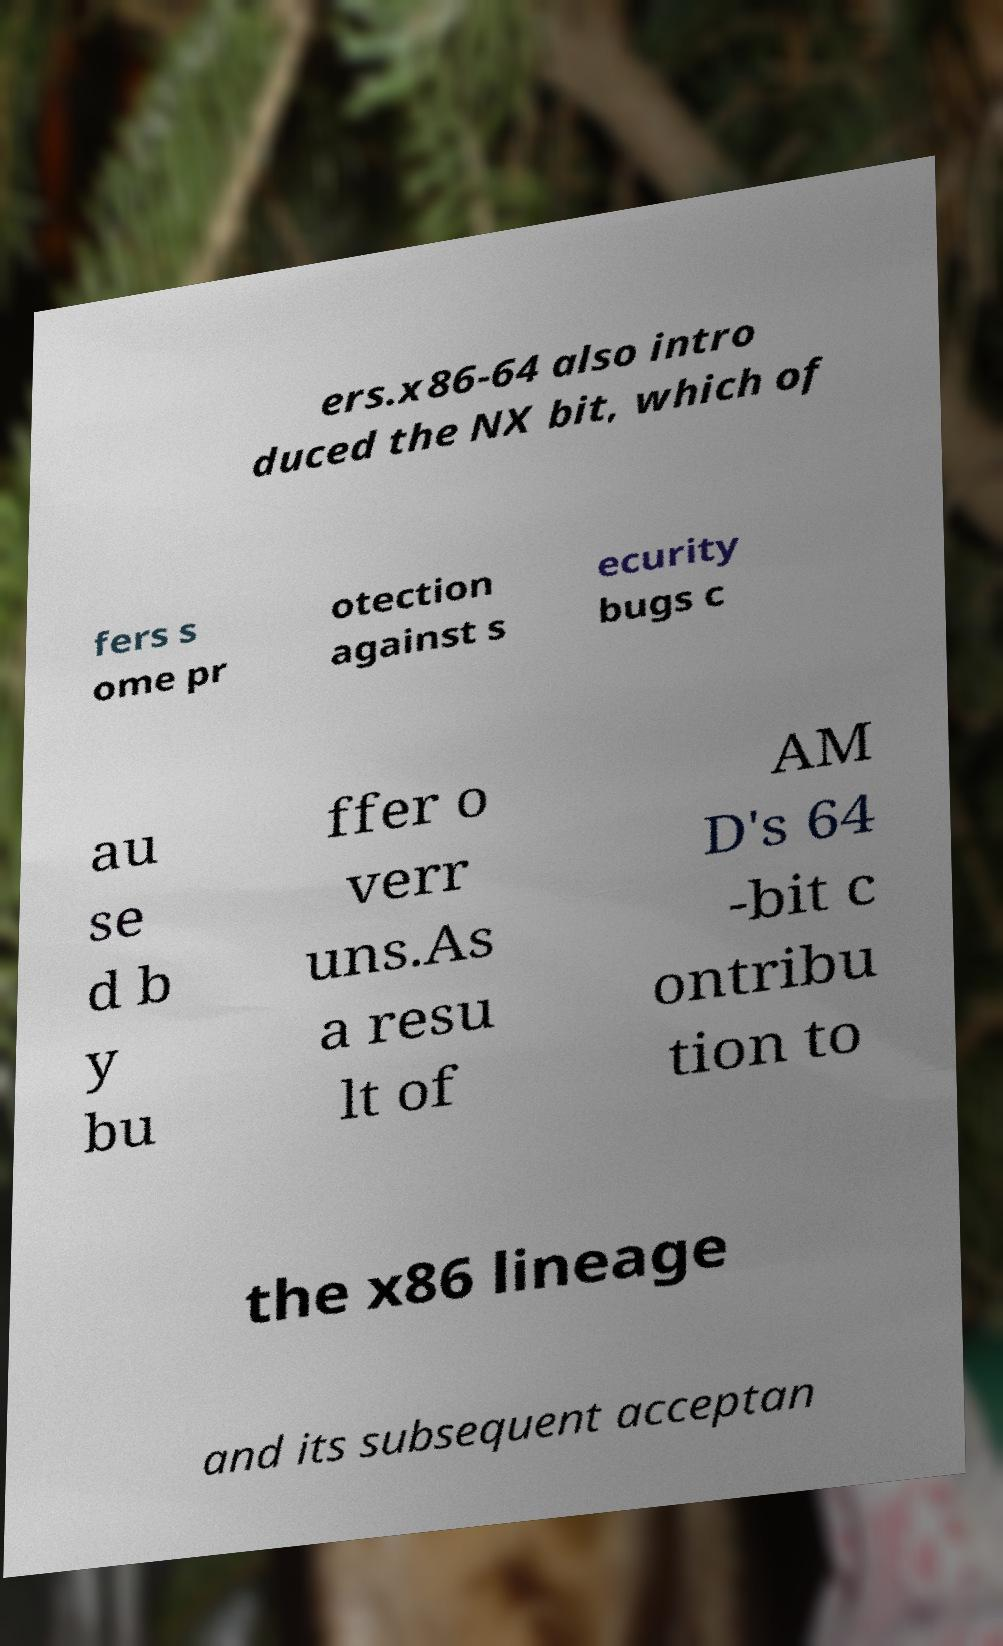What messages or text are displayed in this image? I need them in a readable, typed format. ers.x86-64 also intro duced the NX bit, which of fers s ome pr otection against s ecurity bugs c au se d b y bu ffer o verr uns.As a resu lt of AM D's 64 -bit c ontribu tion to the x86 lineage and its subsequent acceptan 